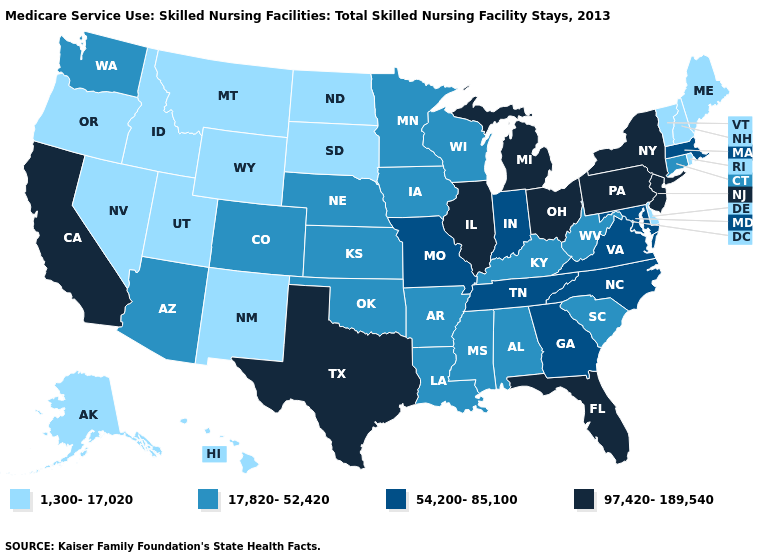What is the lowest value in states that border Indiana?
Write a very short answer. 17,820-52,420. What is the lowest value in the USA?
Give a very brief answer. 1,300-17,020. Name the states that have a value in the range 17,820-52,420?
Concise answer only. Alabama, Arizona, Arkansas, Colorado, Connecticut, Iowa, Kansas, Kentucky, Louisiana, Minnesota, Mississippi, Nebraska, Oklahoma, South Carolina, Washington, West Virginia, Wisconsin. What is the value of Kansas?
Give a very brief answer. 17,820-52,420. Is the legend a continuous bar?
Concise answer only. No. Does South Carolina have the same value as New York?
Concise answer only. No. Name the states that have a value in the range 17,820-52,420?
Be succinct. Alabama, Arizona, Arkansas, Colorado, Connecticut, Iowa, Kansas, Kentucky, Louisiana, Minnesota, Mississippi, Nebraska, Oklahoma, South Carolina, Washington, West Virginia, Wisconsin. Does Nevada have the lowest value in the USA?
Concise answer only. Yes. Does Indiana have a higher value than Alaska?
Concise answer only. Yes. Among the states that border North Dakota , does Minnesota have the highest value?
Write a very short answer. Yes. Name the states that have a value in the range 97,420-189,540?
Be succinct. California, Florida, Illinois, Michigan, New Jersey, New York, Ohio, Pennsylvania, Texas. What is the value of Nebraska?
Be succinct. 17,820-52,420. Name the states that have a value in the range 97,420-189,540?
Concise answer only. California, Florida, Illinois, Michigan, New Jersey, New York, Ohio, Pennsylvania, Texas. Does Montana have the lowest value in the West?
Keep it brief. Yes. Among the states that border Rhode Island , which have the lowest value?
Keep it brief. Connecticut. 